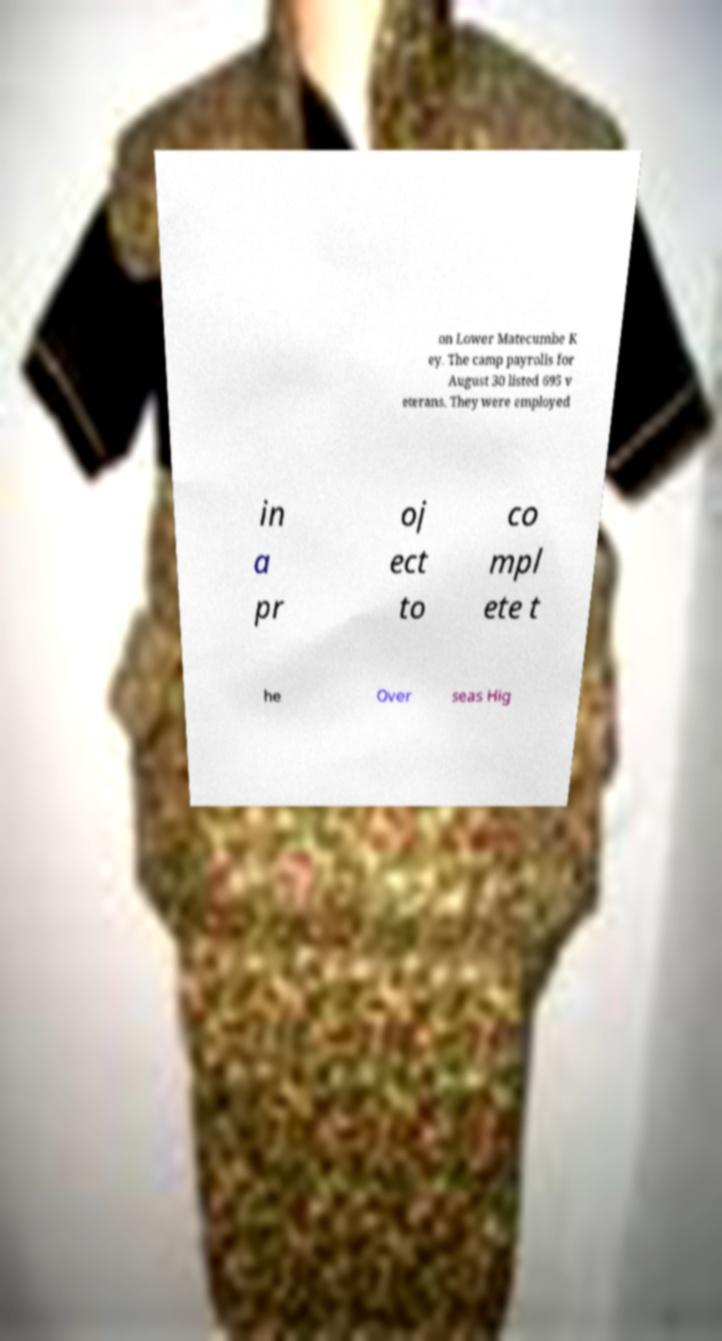Can you accurately transcribe the text from the provided image for me? on Lower Matecumbe K ey. The camp payrolls for August 30 listed 695 v eterans. They were employed in a pr oj ect to co mpl ete t he Over seas Hig 